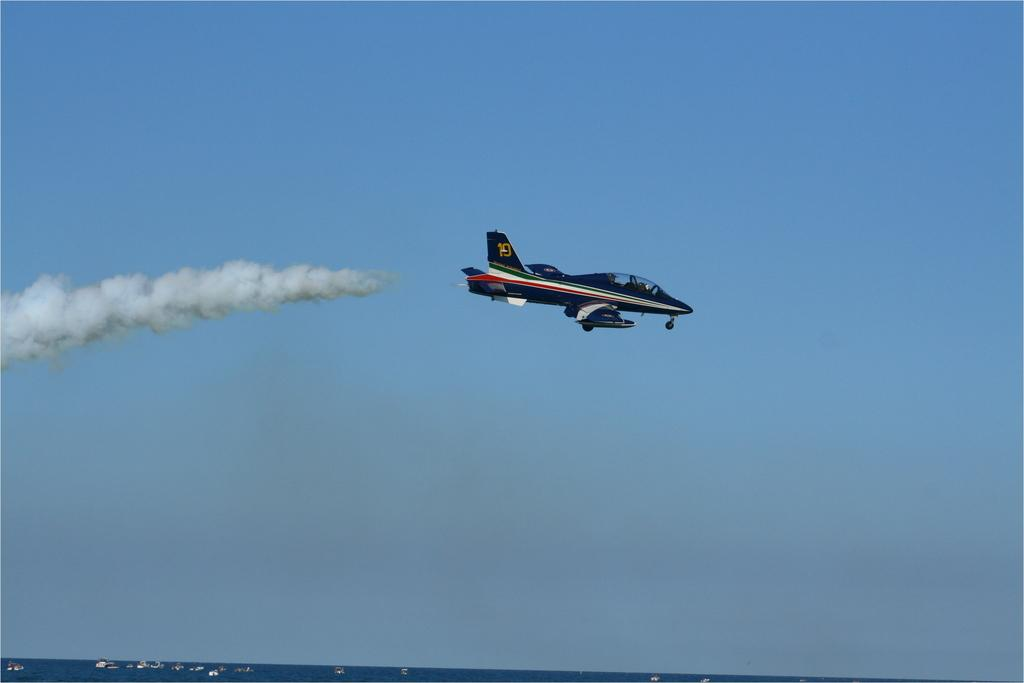<image>
Describe the image concisely. A plane with number 10 on its tail is flying in the sky. 